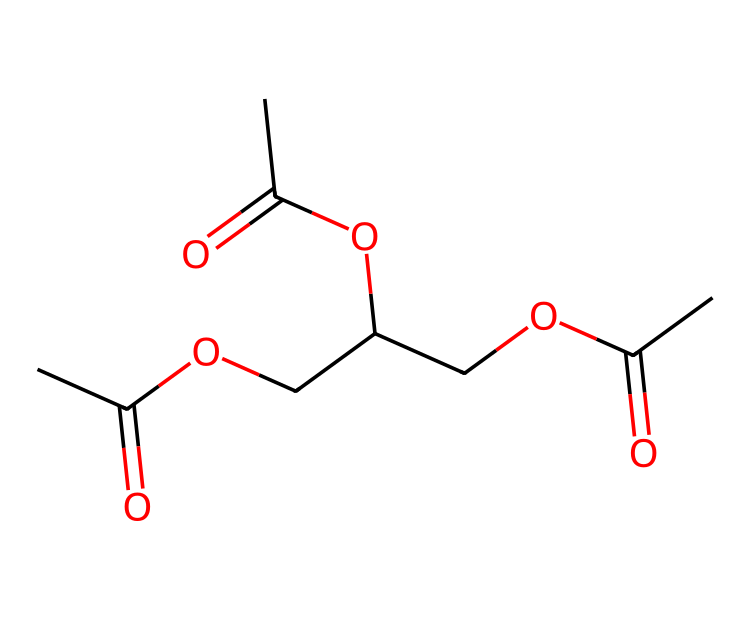What is the total number of carbon atoms in triacetin? By analyzing the SMILES representation, we count three distinct segments of "C(C)=O," which each contribute two carbon atoms, plus one carbon in the ether bridge linking the segments, resulting in a total of 9 carbon atoms.
Answer: 9 How many ester functional groups are present in triacetin? The SMILES indicates three segments with "C(=O)O," each representing an ester functional group, which totals three ester groups in the molecule.
Answer: 3 What is the main functional group in triacetin? Noticing the repeated "C(=O)O" structure in the SMILES, we identify that the ester functional group is the primary functional group throughout the triacetin molecule.
Answer: ester Which part of the molecule indicates it is an ester? The presence of the "C(=O)O" arrangement specifically identifies the functional groups as esters, indicated by the carbonyl (C=O) connected to an alkoxy (O-R) group.
Answer: C(=O)O What is the molecular formula of triacetin? By counting all atoms represented in the SMILES notation (9 carbons, 14 hydrogens, and 6 oxygens), the molecular formula can be deduced as C9H16O6.
Answer: C9H16O6 